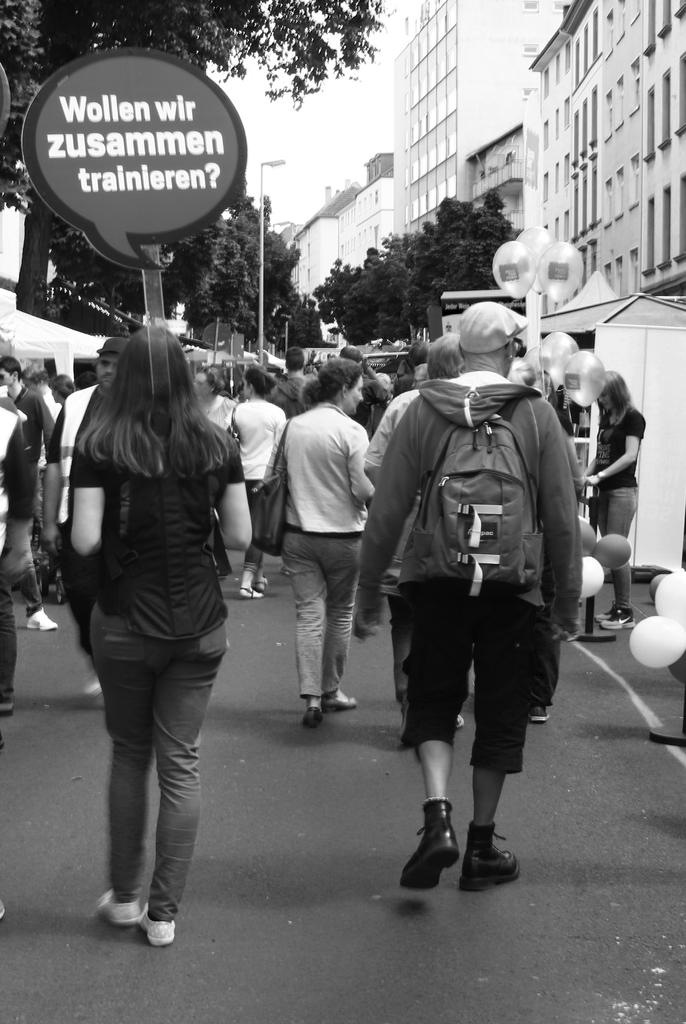What is the color scheme of the image? The image is black and white. What can be seen in the image besides the color scheme? There are people, buildings, trees, poles, balloons, tents, the ground, and the sky visible in the image. What might be used for communication or displaying information in the image? There is a board with text in the image. Can you tell me how many mice are hiding under the tents in the image? There are no mice present in the image; it features people, buildings, trees, poles, balloons, tents, the ground, and the sky. What type of gun is being used by the people in the image? There are no guns present in the image; it features people, buildings, trees, poles, balloons, tents, the ground, and the sky. 